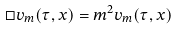<formula> <loc_0><loc_0><loc_500><loc_500>\Box v _ { m } ( \tau , { x } ) = m ^ { 2 } v _ { m } ( \tau , { x } )</formula> 